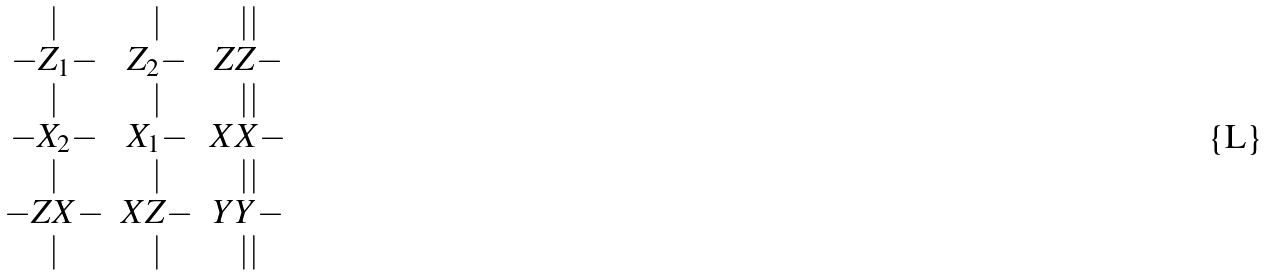Convert formula to latex. <formula><loc_0><loc_0><loc_500><loc_500>\begin{array} { c c c } | & | & | | \\ - Z _ { 1 } - & Z _ { 2 } - & Z Z - \\ | & | & | | \\ - X _ { 2 } - & X _ { 1 } - & X X - \\ | & | & | | \\ - Z X - & X Z - & Y Y - \\ | & | & | | \\ \end{array}</formula> 